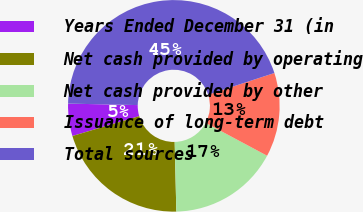Convert chart. <chart><loc_0><loc_0><loc_500><loc_500><pie_chart><fcel>Years Ended December 31 (in<fcel>Net cash provided by operating<fcel>Net cash provided by other<fcel>Issuance of long-term debt<fcel>Total sources<nl><fcel>4.94%<fcel>20.78%<fcel>16.81%<fcel>12.84%<fcel>44.64%<nl></chart> 